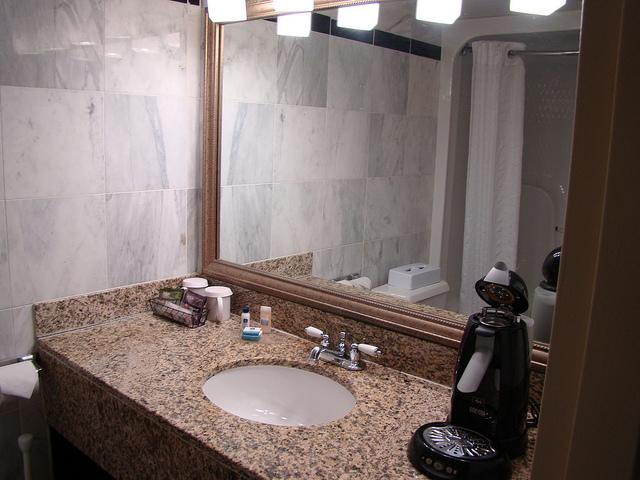Who folded the toilet paper roll into a point to the left of the sink? maid 